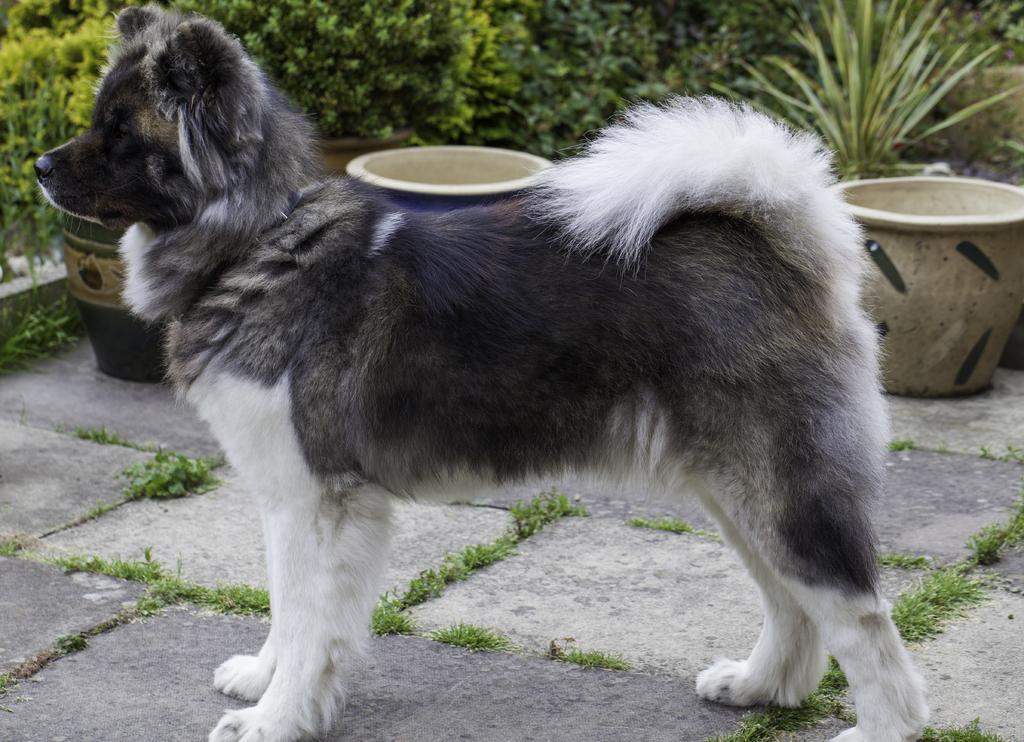In one or two sentences, can you explain what this image depicts? This image consists of a dog in black and white color. At the bottom, there is ground. In the background, there are plants. 